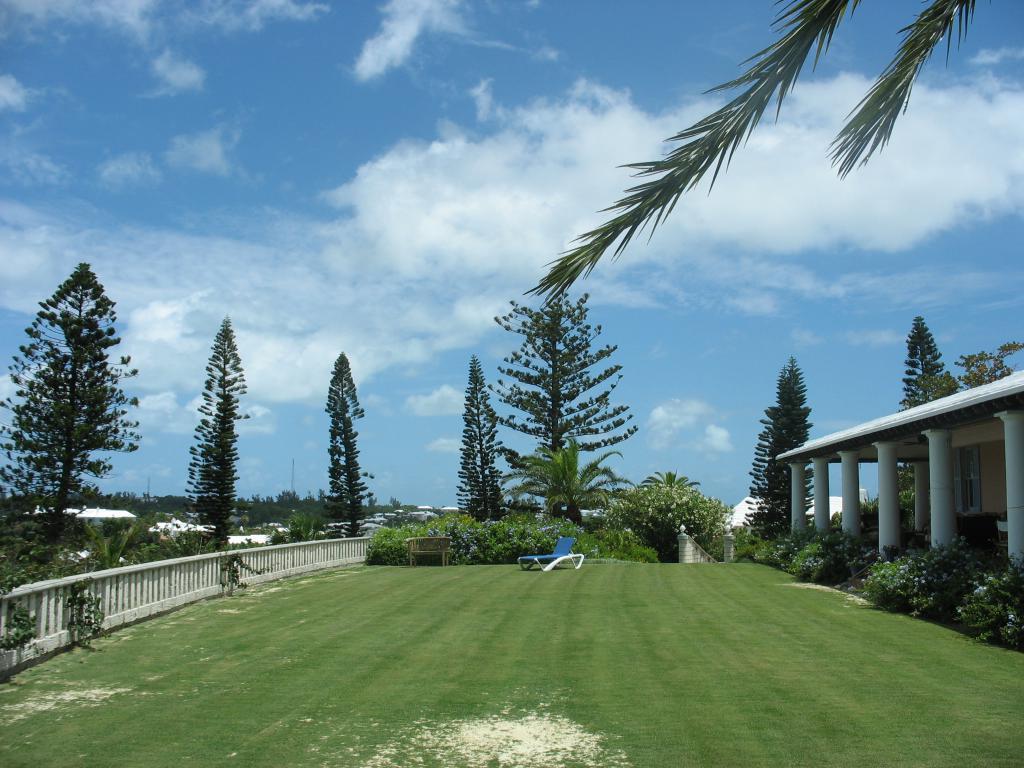In one or two sentences, can you explain what this image depicts? It is a lawn outside the house and there is a beautiful garden and in the garden there is a blue chair and there is a fencing around the garden and behind the fencing there are tall trees. 